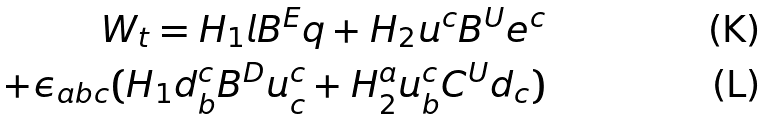Convert formula to latex. <formula><loc_0><loc_0><loc_500><loc_500>W _ { t } = H _ { 1 } l B ^ { E } q + H _ { 2 } u ^ { c } B ^ { U } e ^ { c } \\ + \epsilon _ { a b c } ( H _ { 1 } d ^ { c } _ { b } B ^ { D } u ^ { c } _ { c } + H _ { 2 } ^ { a } u ^ { c } _ { b } C ^ { U } d _ { c } )</formula> 